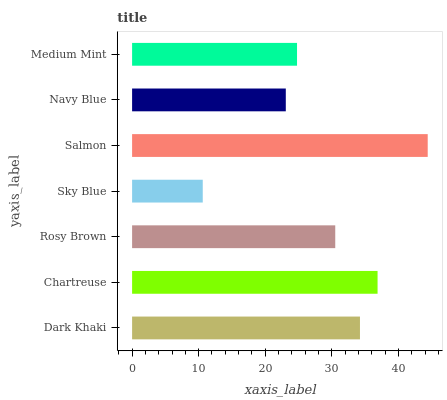Is Sky Blue the minimum?
Answer yes or no. Yes. Is Salmon the maximum?
Answer yes or no. Yes. Is Chartreuse the minimum?
Answer yes or no. No. Is Chartreuse the maximum?
Answer yes or no. No. Is Chartreuse greater than Dark Khaki?
Answer yes or no. Yes. Is Dark Khaki less than Chartreuse?
Answer yes or no. Yes. Is Dark Khaki greater than Chartreuse?
Answer yes or no. No. Is Chartreuse less than Dark Khaki?
Answer yes or no. No. Is Rosy Brown the high median?
Answer yes or no. Yes. Is Rosy Brown the low median?
Answer yes or no. Yes. Is Navy Blue the high median?
Answer yes or no. No. Is Sky Blue the low median?
Answer yes or no. No. 